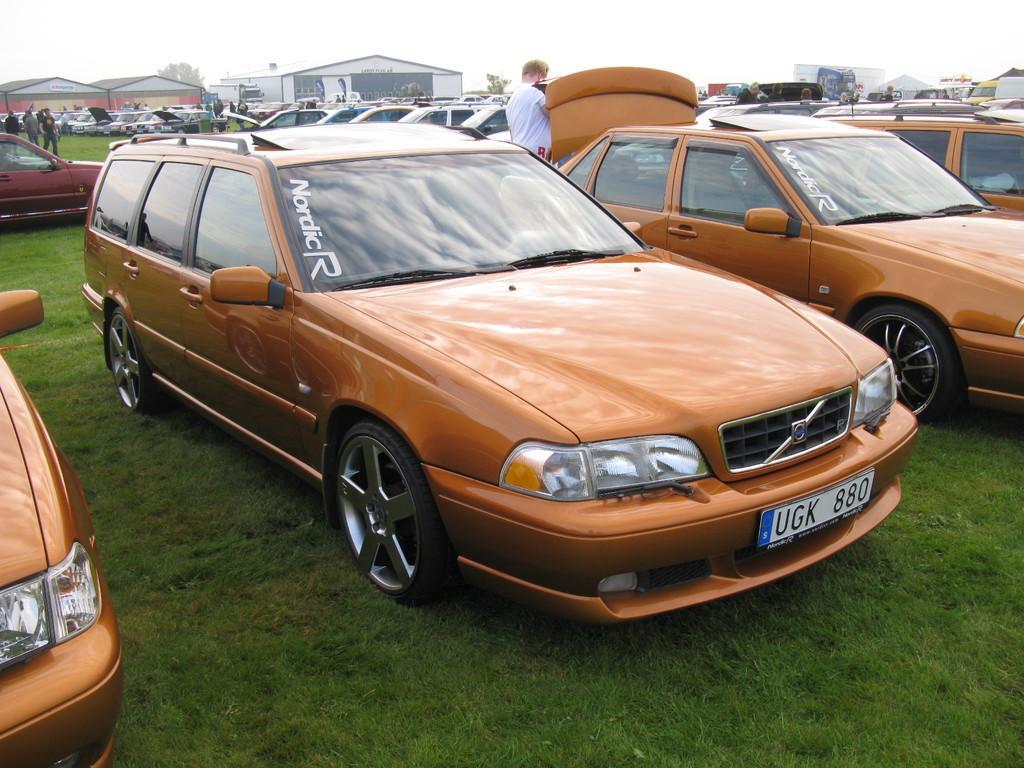Could you give a brief overview of what you see in this image? In this image, we can see some cars and sheds. There is a person at the top of the image. 